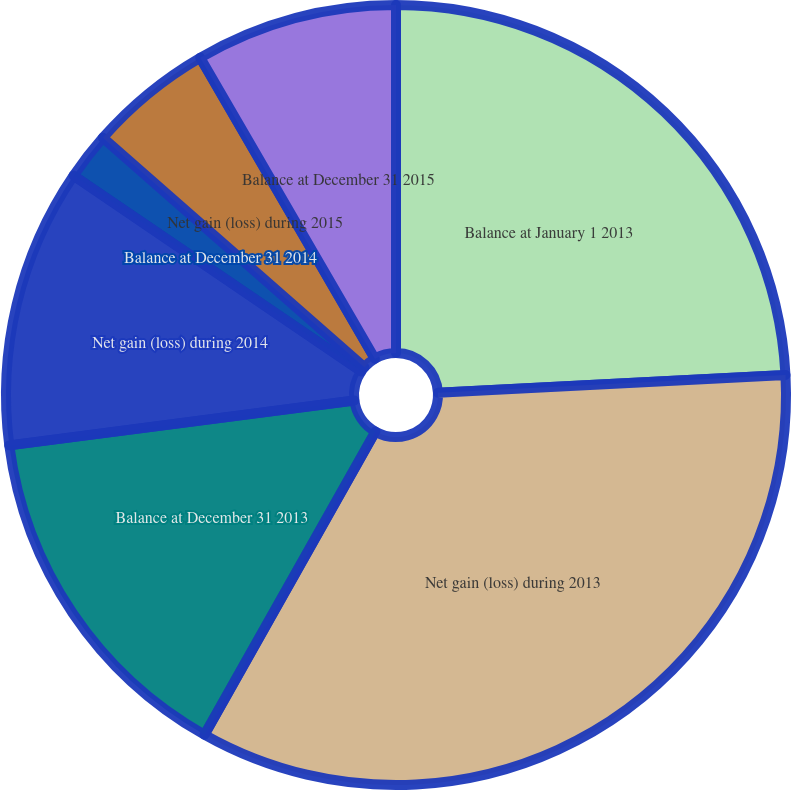<chart> <loc_0><loc_0><loc_500><loc_500><pie_chart><fcel>Balance at January 1 2013<fcel>Net gain (loss) during 2013<fcel>Balance at December 31 2013<fcel>Net gain (loss) during 2014<fcel>Balance at December 31 2014<fcel>Net gain (loss) during 2015<fcel>Balance at December 31 2015<nl><fcel>24.18%<fcel>33.99%<fcel>14.77%<fcel>11.57%<fcel>1.96%<fcel>5.16%<fcel>8.37%<nl></chart> 